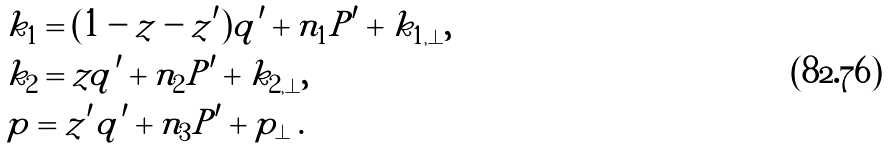<formula> <loc_0><loc_0><loc_500><loc_500>& k _ { 1 } = ( 1 - z - z ^ { \prime } ) q ^ { \prime } + n _ { 1 } P ^ { \prime } + k _ { 1 , \perp } , \\ & k _ { 2 } = z q ^ { \prime } + n _ { 2 } P ^ { \prime } + k _ { 2 , \perp } , \\ & p = z ^ { \prime } q ^ { \prime } + n _ { 3 } P ^ { \prime } + p _ { \perp } \, .</formula> 